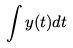<formula> <loc_0><loc_0><loc_500><loc_500>\int y ( t ) d t</formula> 